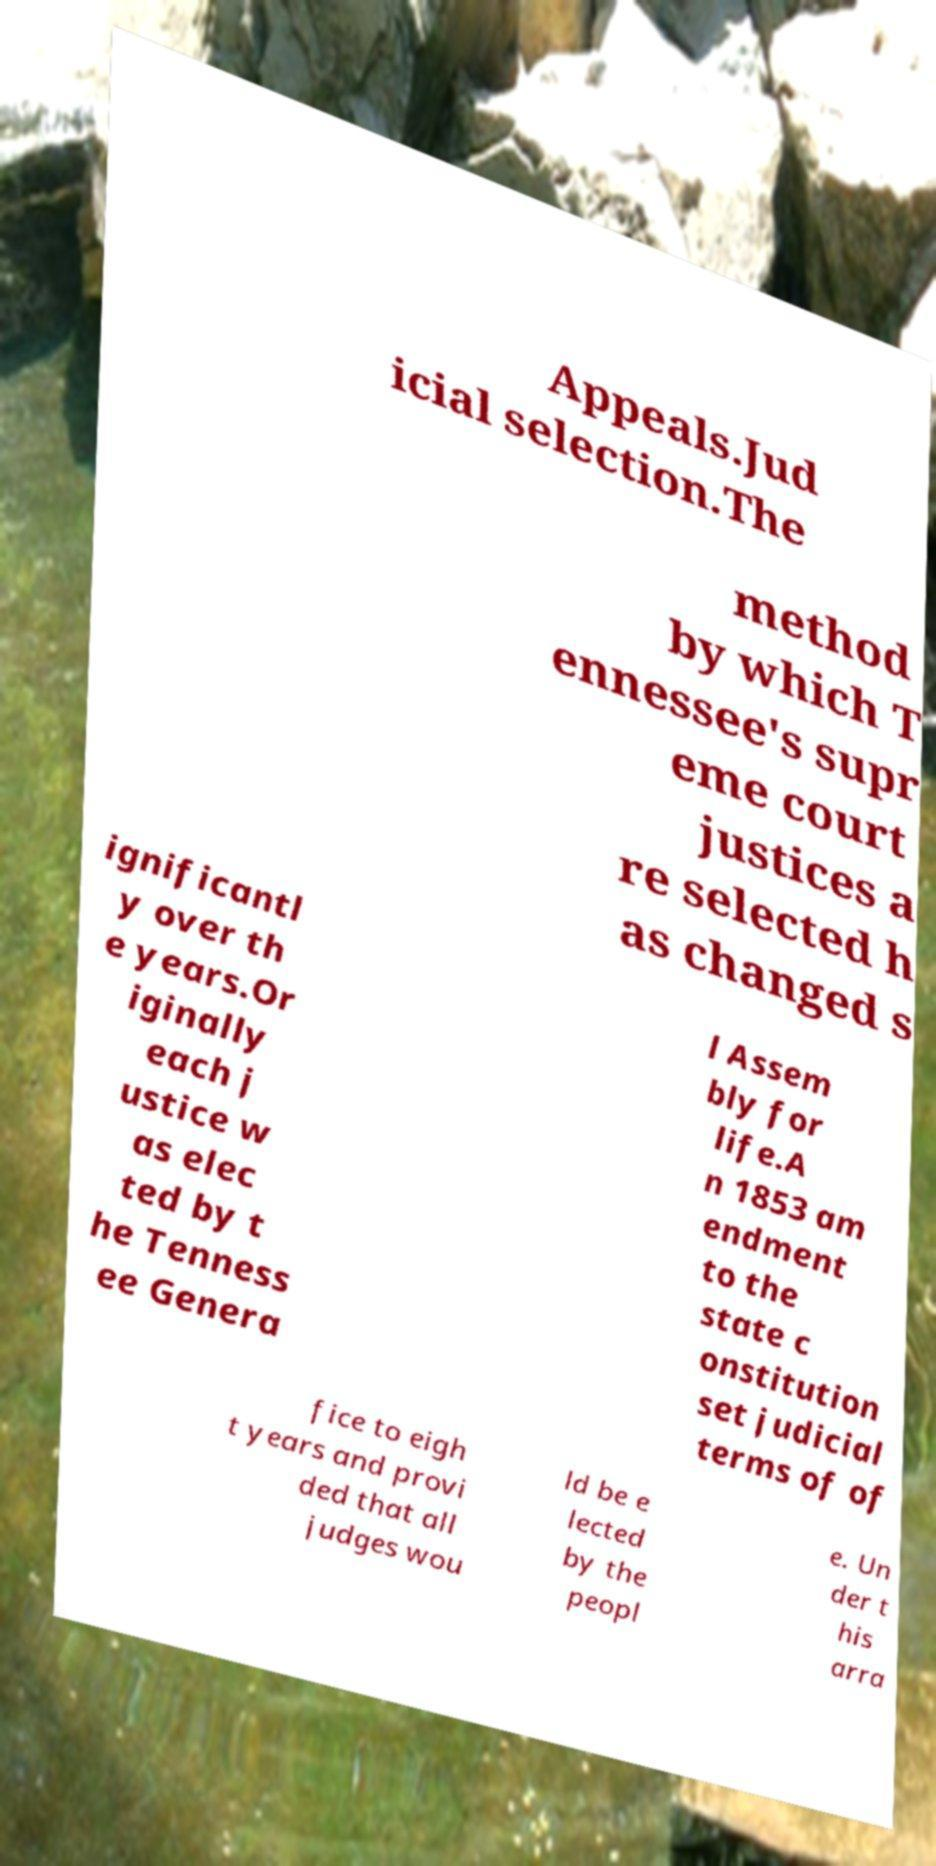Please read and relay the text visible in this image. What does it say? Appeals.Jud icial selection.The method by which T ennessee's supr eme court justices a re selected h as changed s ignificantl y over th e years.Or iginally each j ustice w as elec ted by t he Tenness ee Genera l Assem bly for life.A n 1853 am endment to the state c onstitution set judicial terms of of fice to eigh t years and provi ded that all judges wou ld be e lected by the peopl e. Un der t his arra 